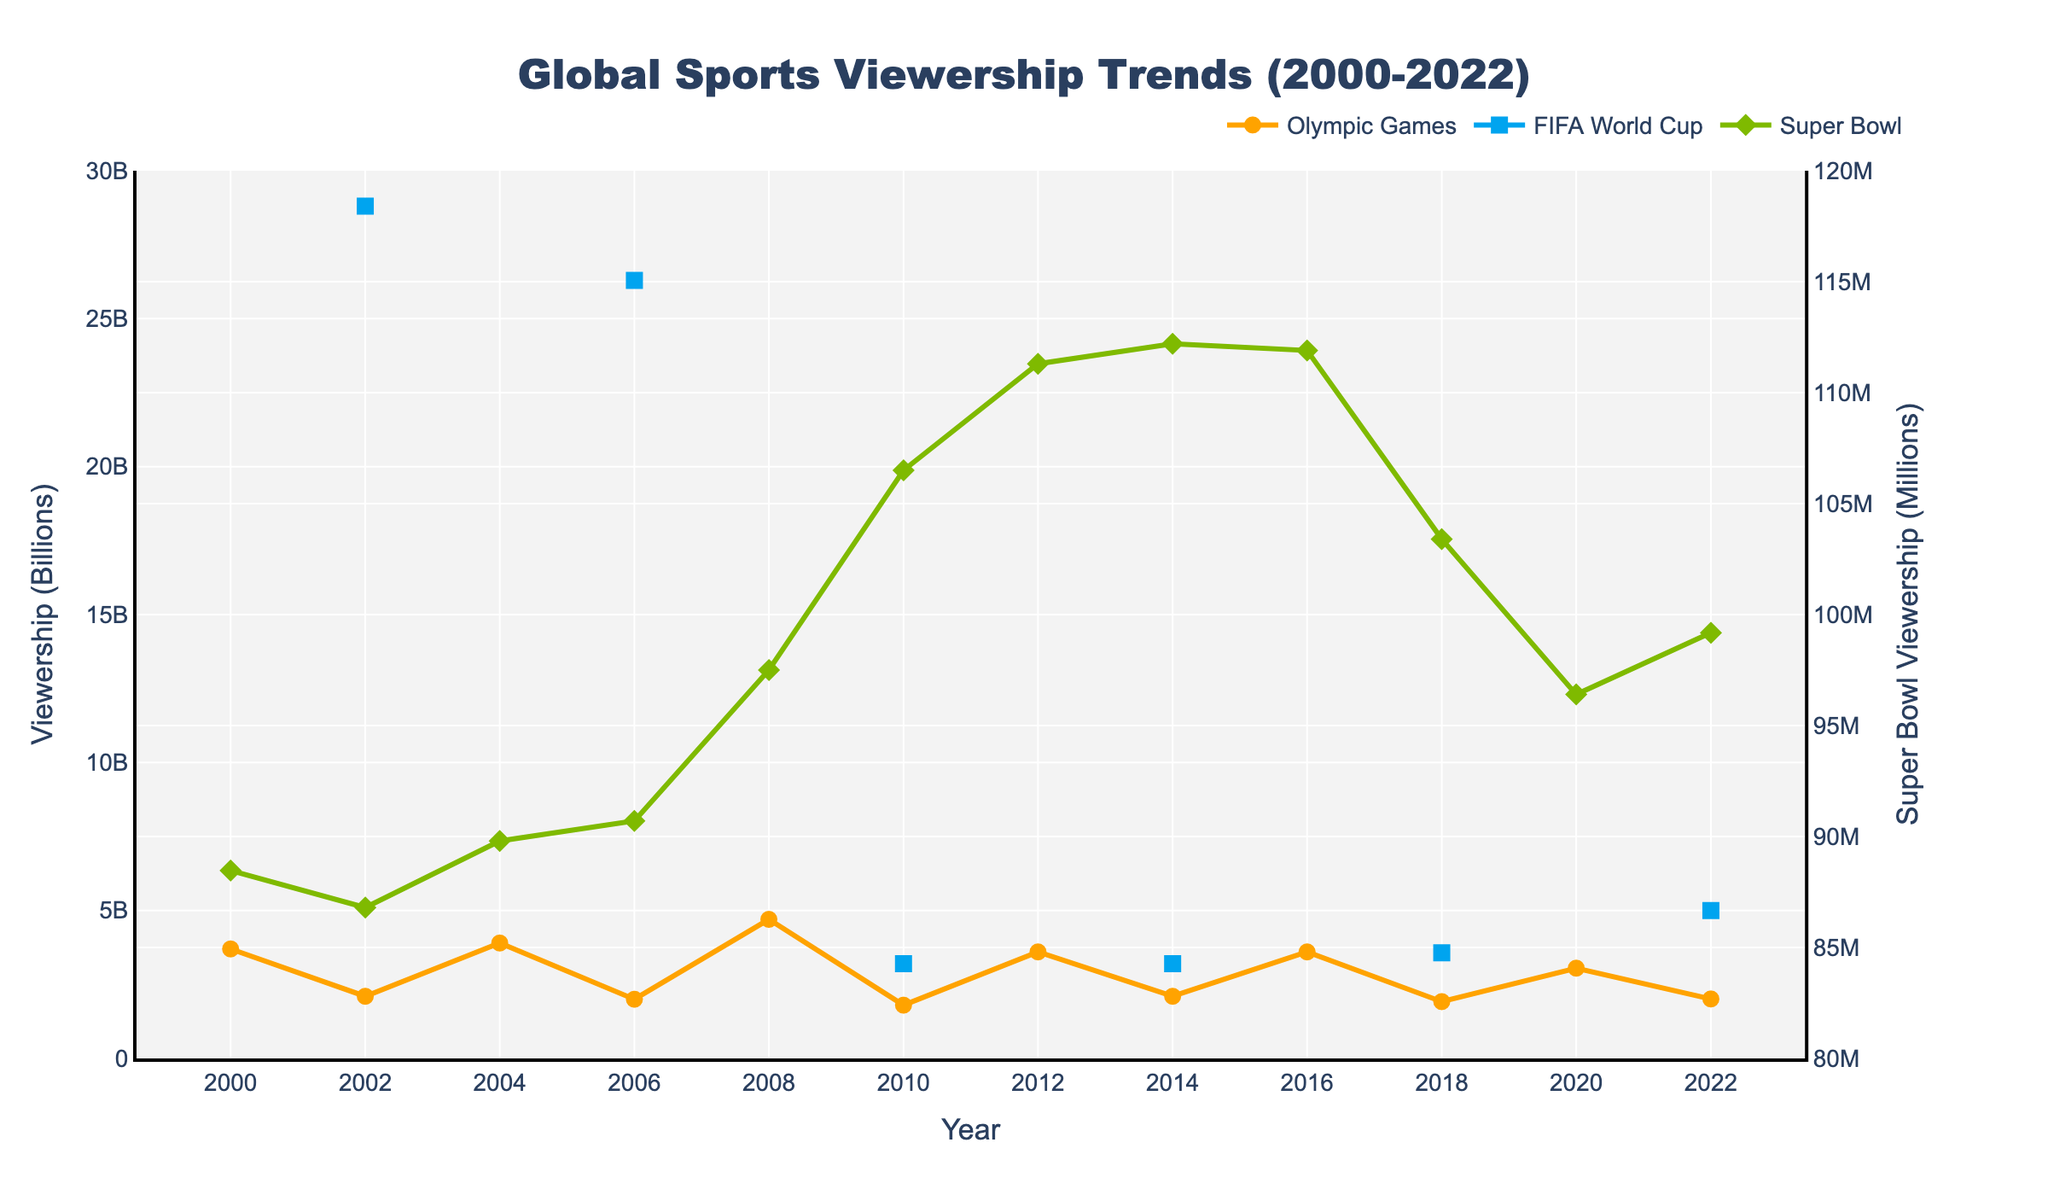How does the viewership of the Olympic Games in 2008 compare to the FIFA World Cup in 2010? The viewership of the Olympic Games in 2008 is 4.7 billion, while the FIFA World Cup in 2010 is 3.2 billion. Thus, the Olympic Games had 1.5 billion more viewers.
Answer: 1.5 billion more Which event had the highest viewership in a single year, and in what year was this? By inspecting the figure, the highest viewership ever recorded was for the FIFA World Cup in 2002, with 28.8 billion viewers.
Answer: FIFA World Cup, 2002 What is the overall trend of Super Bowl viewership from 2000 to 2022? The Super Bowl viewership shows a general upward trend from 88.47 million in 2000 to 99.18 million in 2022, peaking at over 112.2 million in 2014.
Answer: Upward trend In what year did the Olympic Games have the lowest viewership, and how much was it? The Olympic Games had the lowest viewership in 2010 with 1.8 billion viewers.
Answer: 2010, 1.8 billion How do the trends in viewership for the Olympic Games and the FIFA World Cup between 2010 and 2018 compare? Between 2010 and 2018, the FIFA World Cup viewership increased from 3.2 billion to 3.572 billion. In contrast, the Olympic Games' viewership decreased from 3.6 billion to 1.92 billion.
Answer: FIFA World Cup increased; Olympic Games decreased What event experienced a significant drop in viewership from the previous recording, and how much was the drop? The Olympic Games experienced a significant drop from 4.7 billion in 2008 to 1.8 billion in 2010, a drop of 2.9 billion.
Answer: Olympic Games, 2.9 billion Can you identify any significant peaks in viewership for each event? The Olympic Games peaked at 4.7 billion in 2008, the FIFA World Cup peaked at 28.8 billion in 2002, and the Super Bowl peaked at 112.2 million in 2014.
Answer: Olympic Games (2008), FIFA World Cup (2002), Super Bowl (2014) What's the average viewership of the Olympic Games for the years provided? Summing up the viewership numbers for the Olympic Games (3.7 + 2.1 + 3.9 + 2.0 + 4.7 + 1.8 + 3.6 + 2.1 + 3.6 + 1.92 + 3.05 + 2.01) and dividing by 12 gives the average of approximately 2.98 billion.
Answer: 2.98 billion How much did the viewership of the FIFA World Cup increase from 2010 to 2022? The viewership of the FIFA World Cup increased from 3.2 billion in 2010 to 5.0 billion in 2022, an increase of 1.8 billion.
Answer: 1.8 billion 